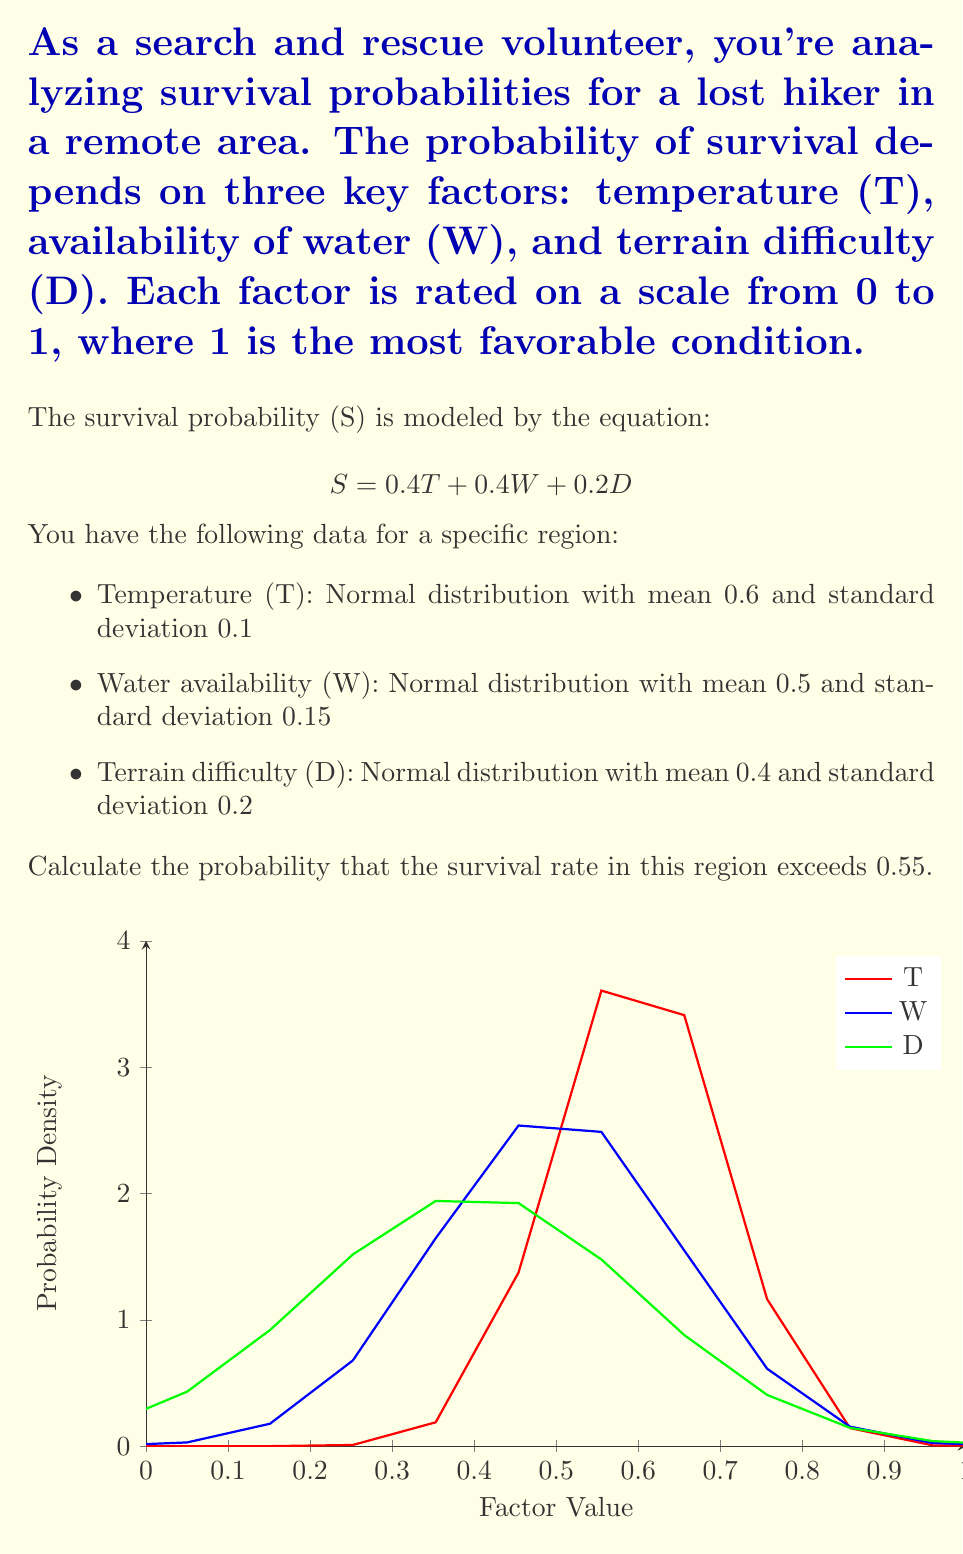Could you help me with this problem? To solve this problem, we need to follow these steps:

1) First, we need to find the mean and variance of the survival probability S.

2) Since S is a linear combination of normally distributed variables, it will also be normally distributed.

3) The mean of S is:
   $$ \mu_S = 0.4\mu_T + 0.4\mu_W + 0.2\mu_D $$
   $$ \mu_S = 0.4(0.6) + 0.4(0.5) + 0.2(0.4) = 0.52 $$

4) The variance of S is:
   $$ \sigma_S^2 = (0.4)^2\sigma_T^2 + (0.4)^2\sigma_W^2 + (0.2)^2\sigma_D^2 $$
   $$ \sigma_S^2 = (0.4)^2(0.1)^2 + (0.4)^2(0.15)^2 + (0.2)^2(0.2)^2 = 0.0052 $$

5) The standard deviation of S is:
   $$ \sigma_S = \sqrt{0.0052} \approx 0.0721 $$

6) Now, we want to find P(S > 0.55). We can standardize this to a Z-score:
   $$ Z = \frac{0.55 - \mu_S}{\sigma_S} = \frac{0.55 - 0.52}{0.0721} \approx 0.4161 $$

7) We need to find P(Z > 0.4161). This is equal to 1 - P(Z < 0.4161).

8) Using a standard normal table or calculator, we find:
   P(Z < 0.4161) ≈ 0.6613

9) Therefore, P(Z > 0.4161) = 1 - 0.6613 = 0.3387

Thus, the probability that the survival rate exceeds 0.55 is approximately 0.3387 or 33.87%.
Answer: 0.3387 